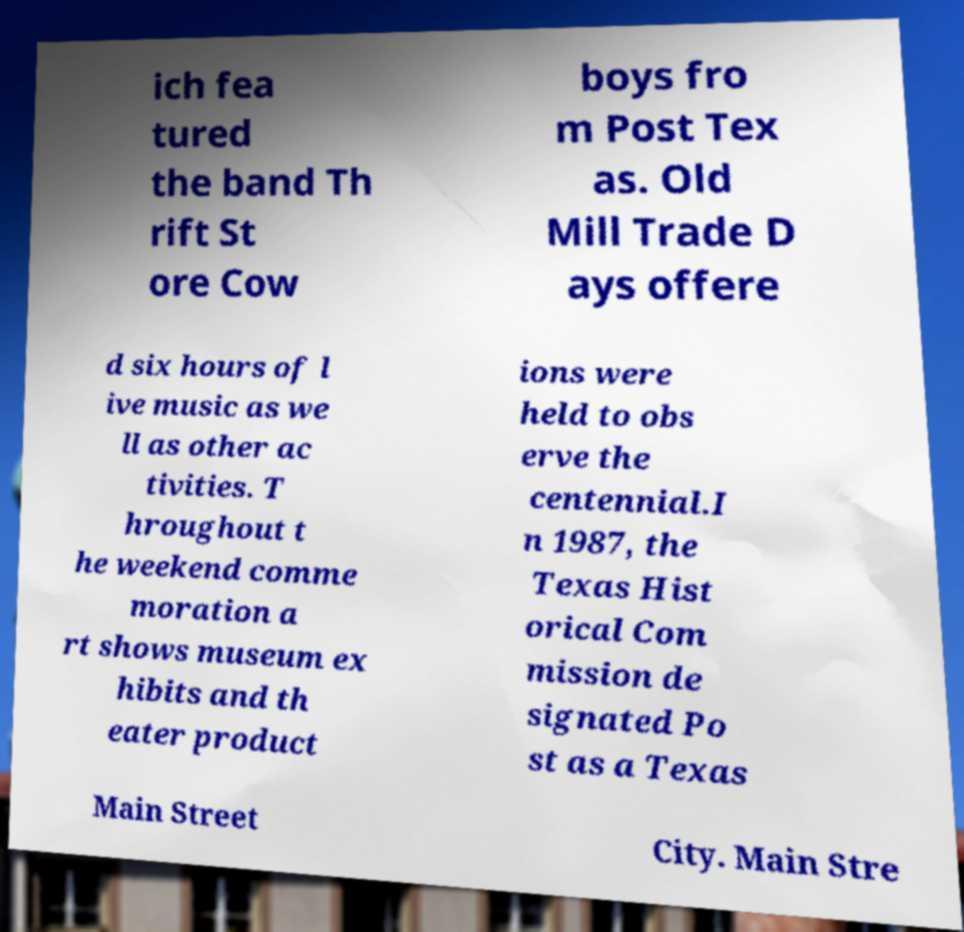Can you read and provide the text displayed in the image?This photo seems to have some interesting text. Can you extract and type it out for me? ich fea tured the band Th rift St ore Cow boys fro m Post Tex as. Old Mill Trade D ays offere d six hours of l ive music as we ll as other ac tivities. T hroughout t he weekend comme moration a rt shows museum ex hibits and th eater product ions were held to obs erve the centennial.I n 1987, the Texas Hist orical Com mission de signated Po st as a Texas Main Street City. Main Stre 